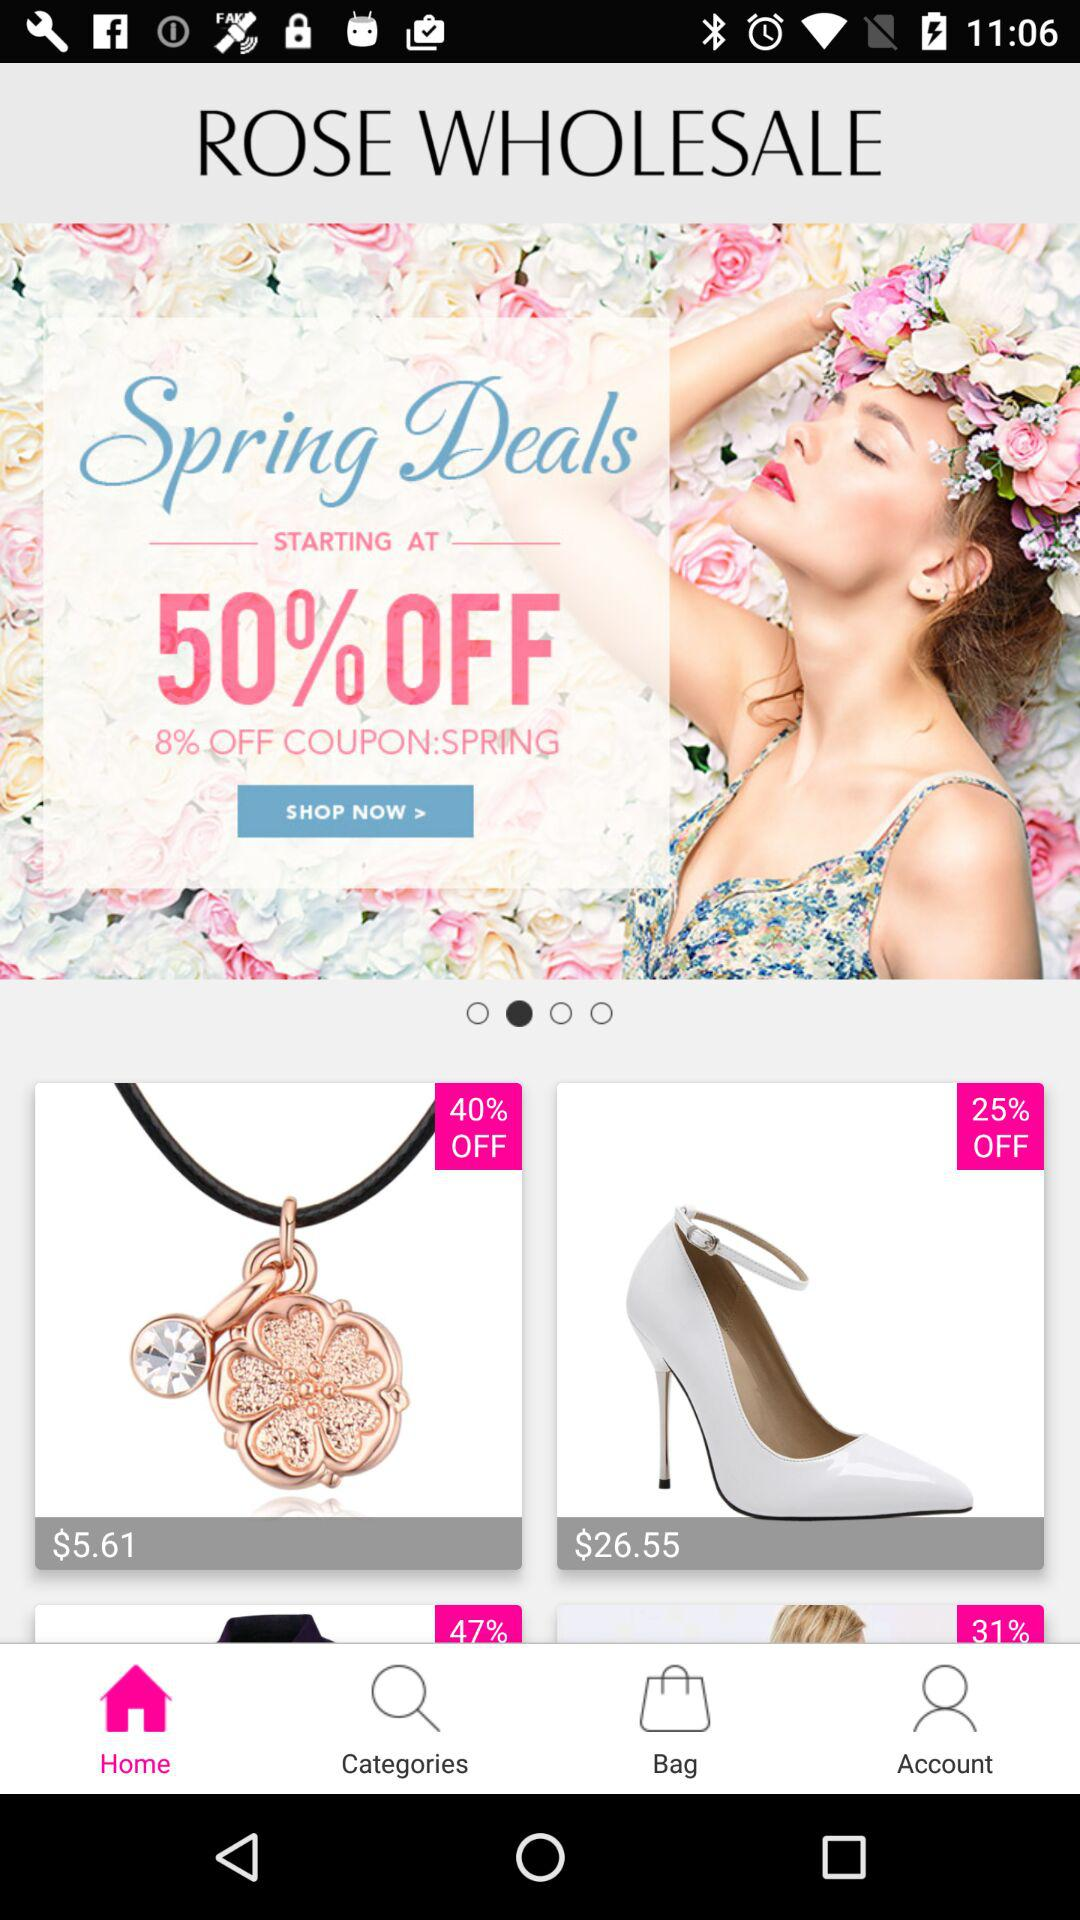What is the price of the item after 40% off? The price of the item after 40% off is $5.61. 